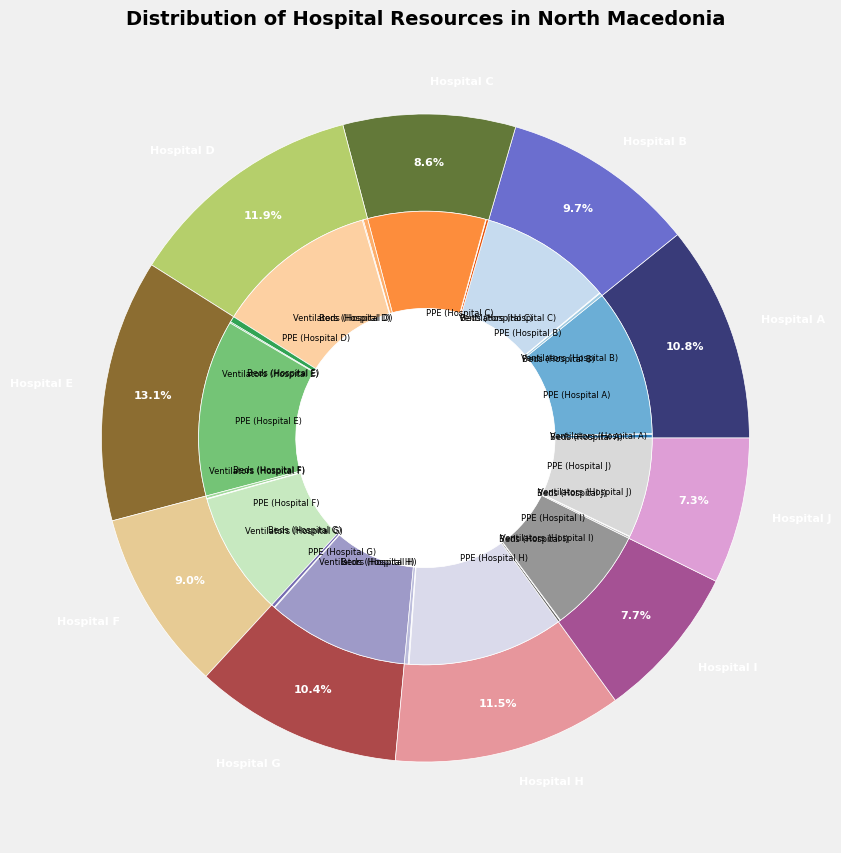What percentage of the total resources is allocated to Hospital A? To find this, you need to sum up the resources of Hospital A and divide it by the total resources for all hospitals. Hospital A's resources are 120 beds, 30 ventilators, and 5000 PPEs; totaling 5150. The total resources for all hospitals is 56,800. Thus, (5150/56800)*100 = 9.1%
Answer: 9.1% Which hospital has the highest percentage of total resources? Look at the outer pie chart and find the segment with the largest portion. Hospital E has the largest portion.
Answer: Hospital E How many more ventilators does Hospital D have than Hospital I? Hospital D has 35 ventilators and Hospital I has 18 ventilators. Subtract the counts: 35 - 18 = 17
Answer: 17 What resource type is depicted in the smallest inner pie slice for Hospital C? In the inner pie chart, find the smallest slice corresponding to Hospital C. It represents the PPE resource type.
Answer: PPE Which hospital has the smallest percentage of their total resources as beds? For each hospital, calculate the percentage of beds out of their total resources and compare. For example, for Hospital A, it's (120/5150)*100 ≈ 2.33%. Similarly, check for other hospitals. Hospital J has the smallest at (60/3475)*100 ≈ 1.73%.
Answer: Hospital J 